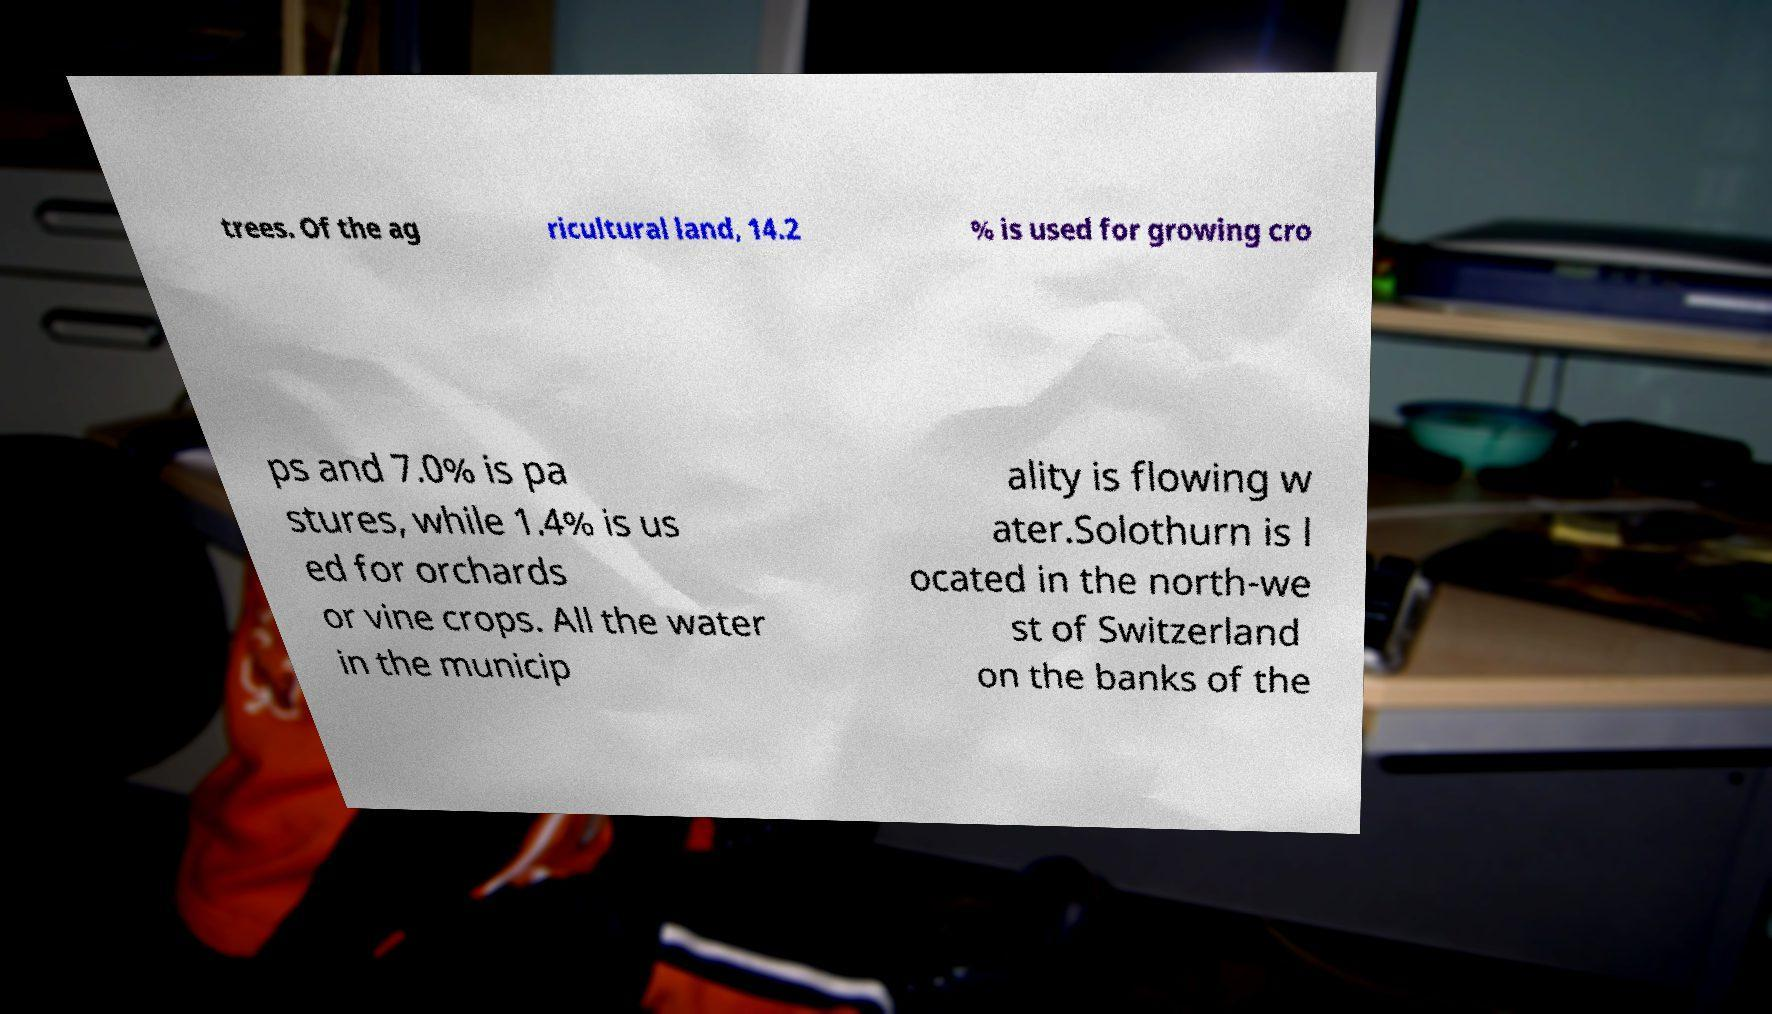Please read and relay the text visible in this image. What does it say? trees. Of the ag ricultural land, 14.2 % is used for growing cro ps and 7.0% is pa stures, while 1.4% is us ed for orchards or vine crops. All the water in the municip ality is flowing w ater.Solothurn is l ocated in the north-we st of Switzerland on the banks of the 